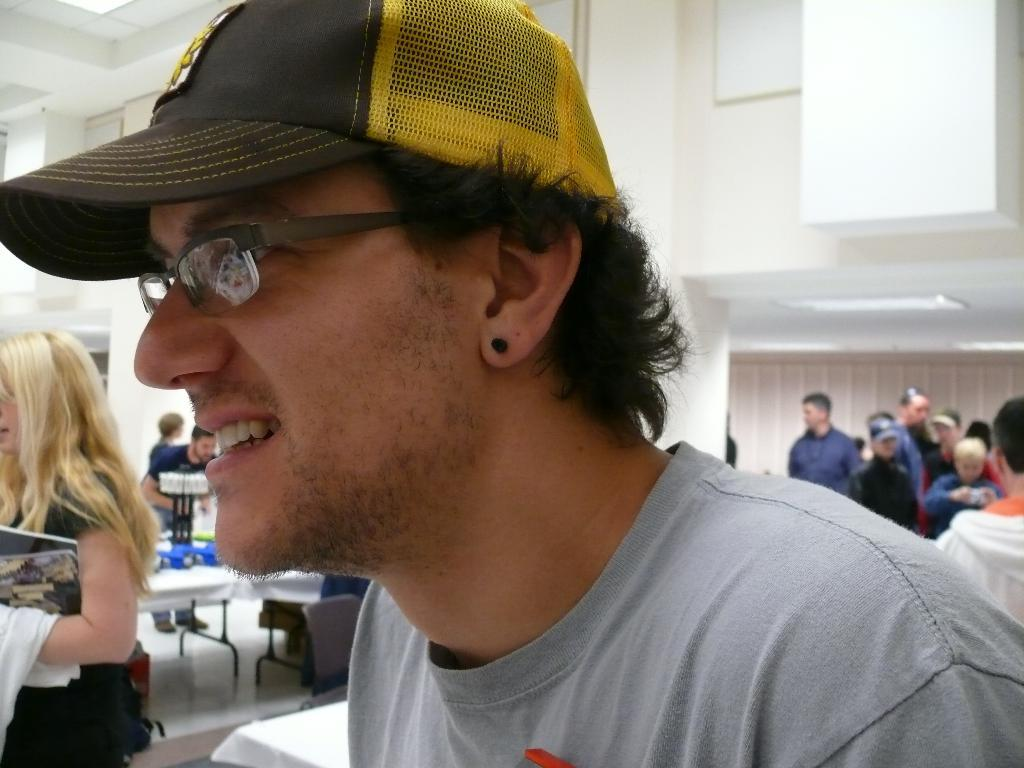Who is the main subject in the foreground of the image? There is a man in the foreground of the image. What can be seen in the background of the image? There are people, tables, and windows in the background of the image. What type of feast is being prepared on the tables in the image? There is no indication of a feast or any food preparation in the image. Can you see any trains or tanks in the image? No, there are no trains or tanks present in the image. 